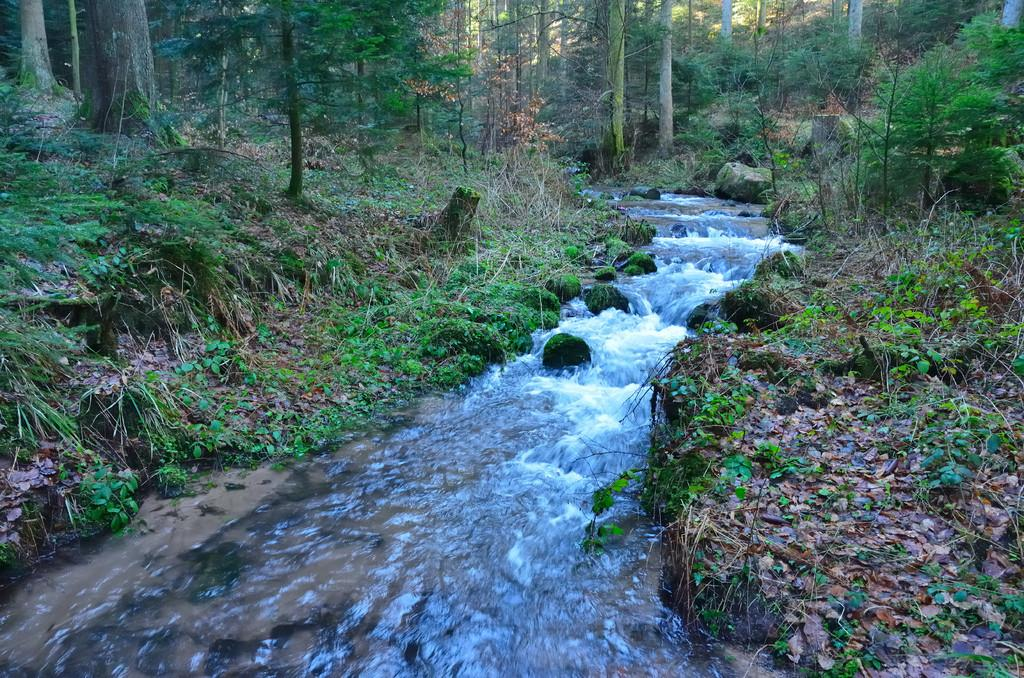What type of vegetation can be seen in the image? There are trees and plants in the image. What other objects can be seen in the image? There are stones and dry leaves present in the image. Is there any indication of water in the image? Yes, there is water flow visible in the image. What type of food does your uncle enjoy eating in the image? There is no uncle or food present in the image. How does the image evoke a sense of disgust? The image does not evoke a sense of disgust, as it features natural elements such as trees, plants, stones, dry leaves, and water flow. 